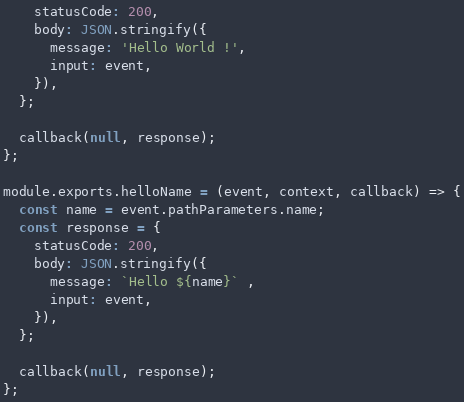Convert code to text. <code><loc_0><loc_0><loc_500><loc_500><_JavaScript_>    statusCode: 200,
    body: JSON.stringify({
      message: 'Hello World !',
      input: event,
    }),
  };

  callback(null, response);
};

module.exports.helloName = (event, context, callback) => {
  const name = event.pathParameters.name;
  const response = {
    statusCode: 200,
    body: JSON.stringify({
      message: `Hello ${name}` ,
      input: event,
    }),
  };

  callback(null, response);
};

</code> 